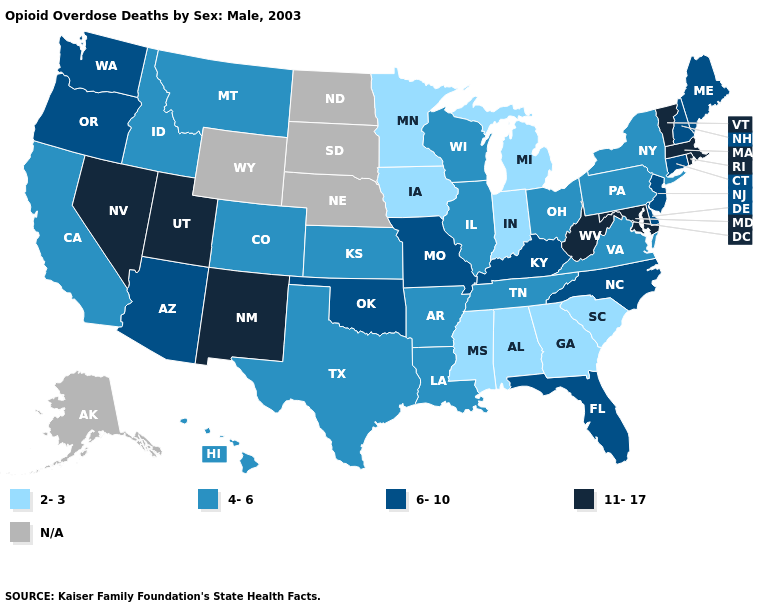Name the states that have a value in the range N/A?
Keep it brief. Alaska, Nebraska, North Dakota, South Dakota, Wyoming. What is the value of Illinois?
Quick response, please. 4-6. What is the value of Wyoming?
Short answer required. N/A. How many symbols are there in the legend?
Write a very short answer. 5. What is the highest value in the West ?
Concise answer only. 11-17. What is the value of Maine?
Give a very brief answer. 6-10. What is the value of New Mexico?
Write a very short answer. 11-17. Which states have the lowest value in the West?
Give a very brief answer. California, Colorado, Hawaii, Idaho, Montana. What is the lowest value in the USA?
Concise answer only. 2-3. Does the first symbol in the legend represent the smallest category?
Give a very brief answer. Yes. Does Missouri have the highest value in the MidWest?
Concise answer only. Yes. What is the value of Oregon?
Keep it brief. 6-10. What is the highest value in states that border Oregon?
Give a very brief answer. 11-17. What is the highest value in the USA?
Keep it brief. 11-17. Among the states that border South Carolina , which have the lowest value?
Concise answer only. Georgia. 